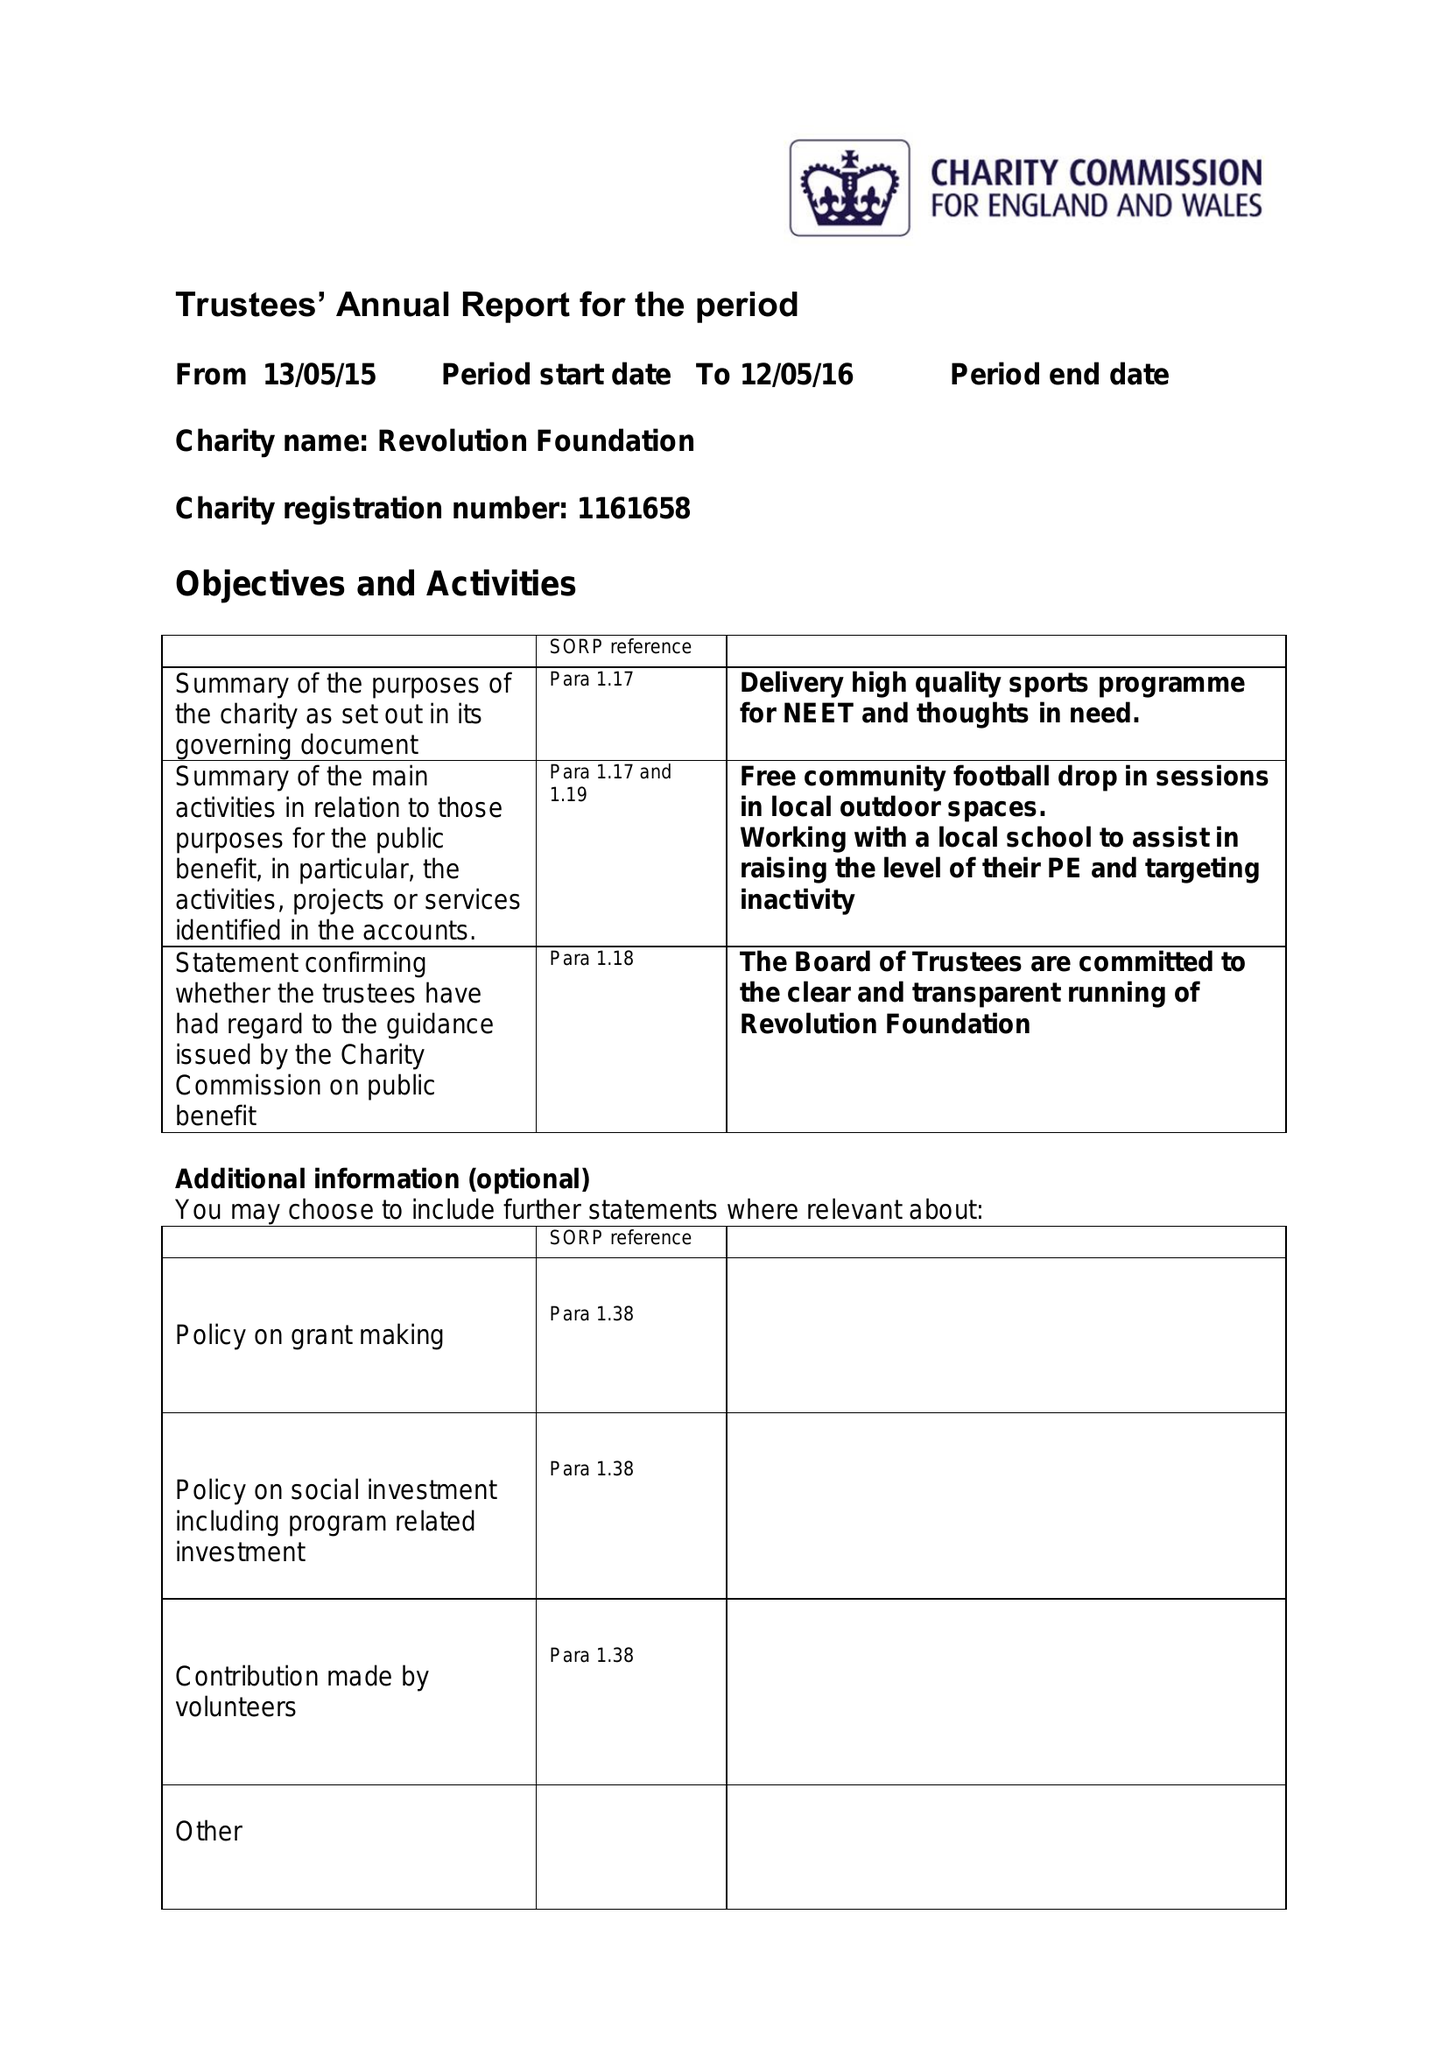What is the value for the address__street_line?
Answer the question using a single word or phrase. 55 HOLLY HILL ROAD 